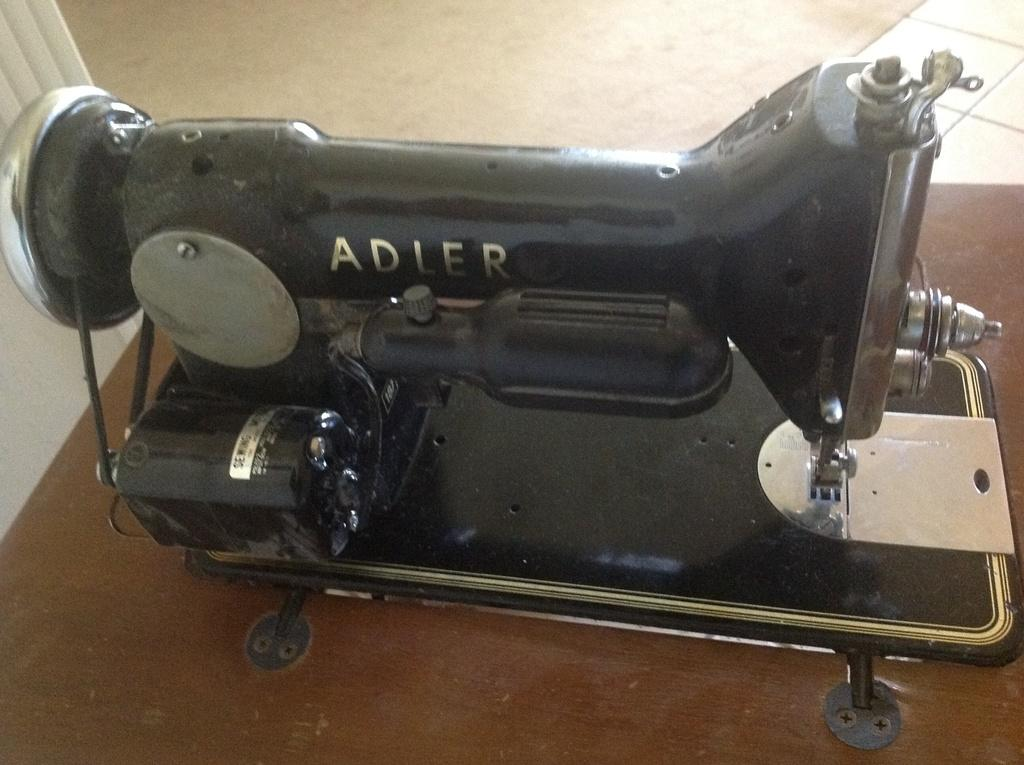What is the main object in the image? There is a sewing machine in the image. Where is the sewing machine located? The sewing machine is placed on a table. What can be seen in the background of the image? There is a floor visible in the background of the image. How many legs does the clam have in the image? There is no clam present in the image, so it is not possible to determine the number of legs it might have. 